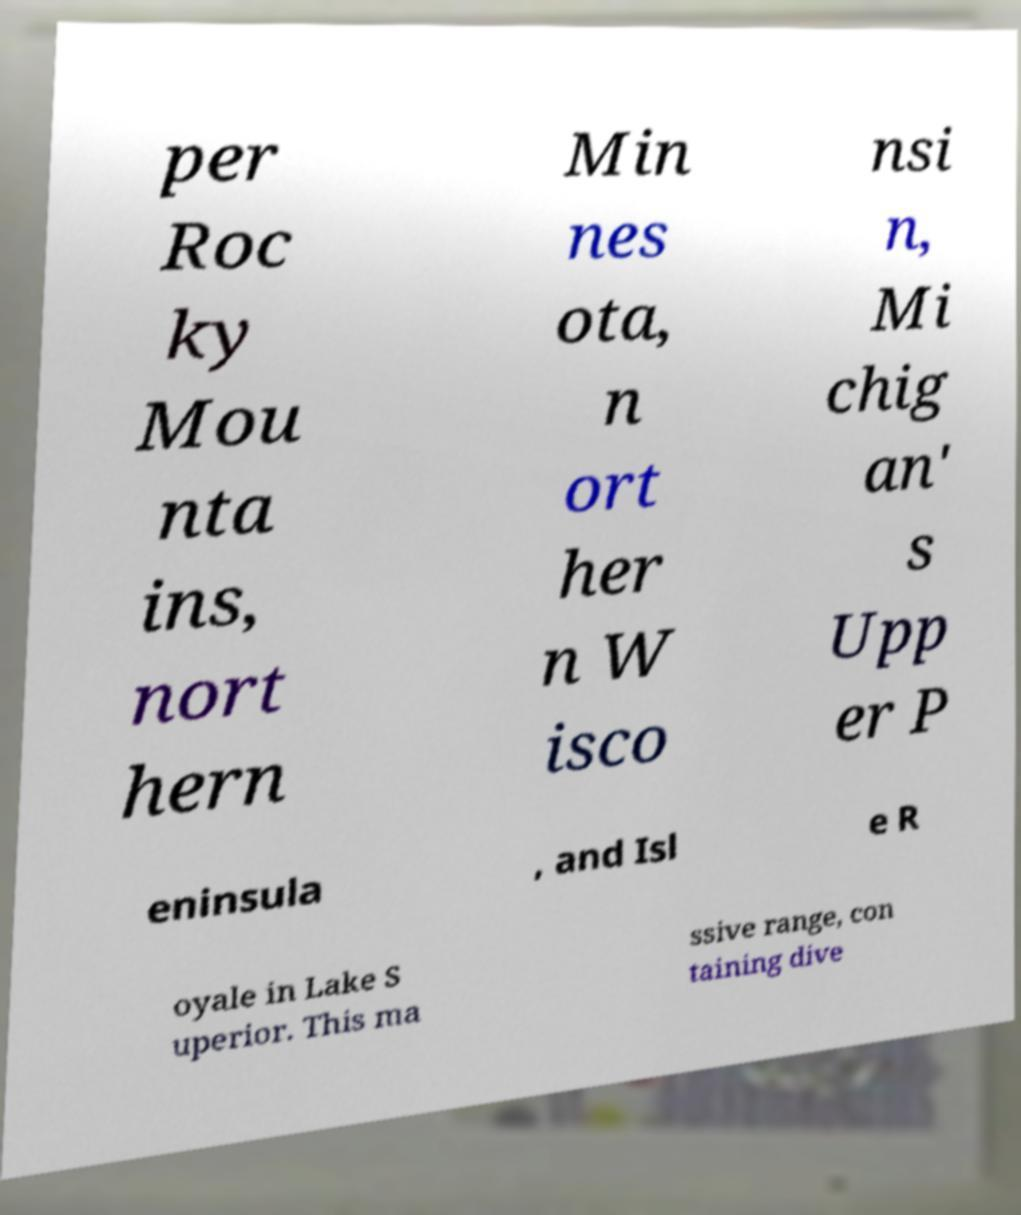Could you assist in decoding the text presented in this image and type it out clearly? per Roc ky Mou nta ins, nort hern Min nes ota, n ort her n W isco nsi n, Mi chig an' s Upp er P eninsula , and Isl e R oyale in Lake S uperior. This ma ssive range, con taining dive 